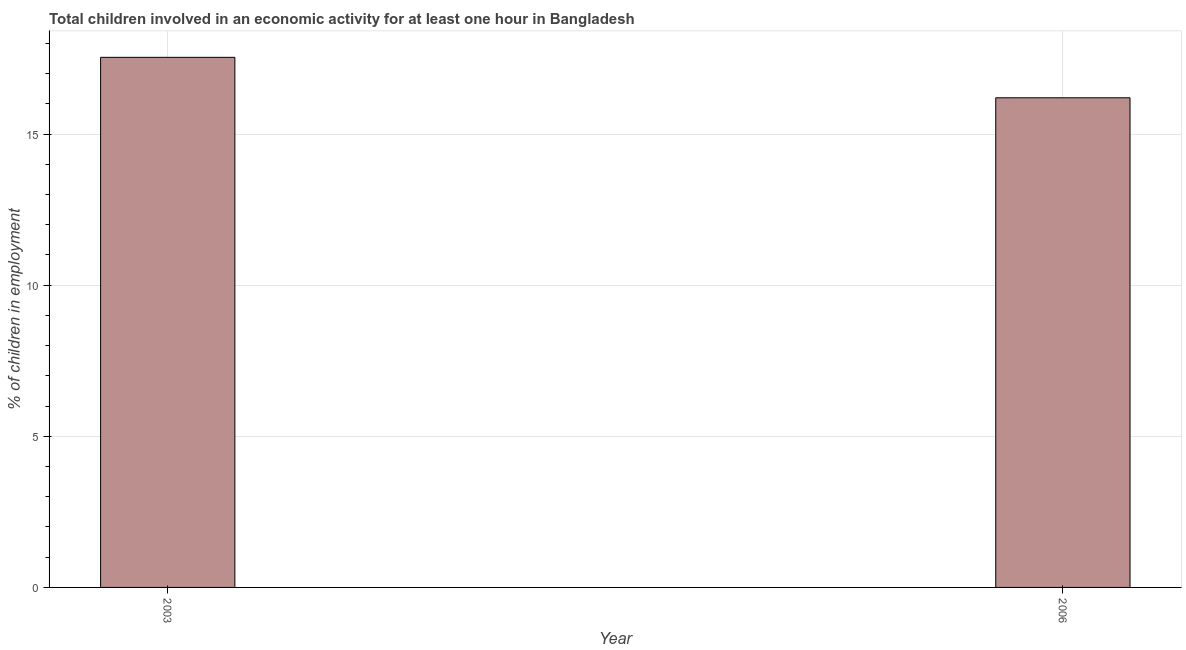Does the graph contain any zero values?
Provide a short and direct response. No. Does the graph contain grids?
Your answer should be very brief. Yes. What is the title of the graph?
Offer a terse response. Total children involved in an economic activity for at least one hour in Bangladesh. What is the label or title of the X-axis?
Your answer should be compact. Year. What is the label or title of the Y-axis?
Provide a short and direct response. % of children in employment. What is the percentage of children in employment in 2006?
Your response must be concise. 16.2. Across all years, what is the maximum percentage of children in employment?
Your answer should be compact. 17.54. Across all years, what is the minimum percentage of children in employment?
Ensure brevity in your answer.  16.2. What is the sum of the percentage of children in employment?
Your answer should be compact. 33.74. What is the difference between the percentage of children in employment in 2003 and 2006?
Your answer should be compact. 1.34. What is the average percentage of children in employment per year?
Your response must be concise. 16.87. What is the median percentage of children in employment?
Offer a very short reply. 16.87. In how many years, is the percentage of children in employment greater than 10 %?
Your response must be concise. 2. Do a majority of the years between 2003 and 2006 (inclusive) have percentage of children in employment greater than 9 %?
Your answer should be compact. Yes. What is the ratio of the percentage of children in employment in 2003 to that in 2006?
Your response must be concise. 1.08. Is the percentage of children in employment in 2003 less than that in 2006?
Offer a terse response. No. What is the % of children in employment in 2003?
Provide a succinct answer. 17.54. What is the difference between the % of children in employment in 2003 and 2006?
Your answer should be very brief. 1.34. What is the ratio of the % of children in employment in 2003 to that in 2006?
Offer a very short reply. 1.08. 